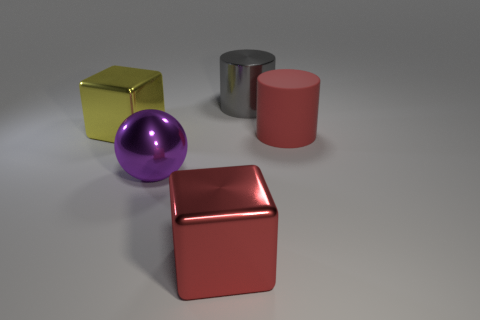Add 2 metallic cubes. How many objects exist? 7 Subtract all cyan cubes. Subtract all purple cylinders. How many cubes are left? 2 Subtract all red cylinders. Subtract all tiny blue cubes. How many objects are left? 4 Add 2 red things. How many red things are left? 4 Add 3 big red objects. How many big red objects exist? 5 Subtract 0 cyan balls. How many objects are left? 5 Subtract all spheres. How many objects are left? 4 